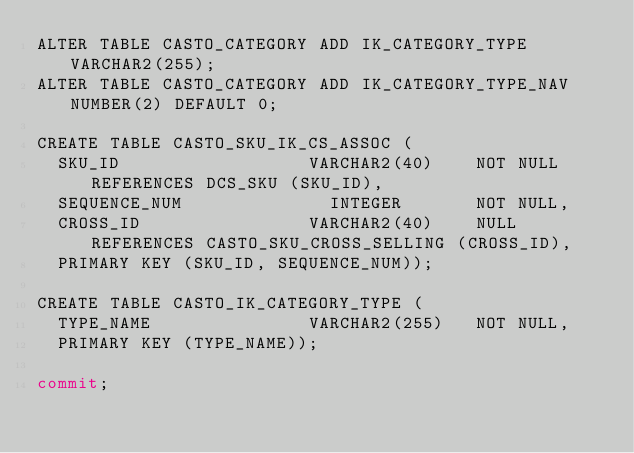<code> <loc_0><loc_0><loc_500><loc_500><_SQL_>ALTER TABLE CASTO_CATEGORY ADD IK_CATEGORY_TYPE	VARCHAR2(255);
ALTER TABLE CASTO_CATEGORY ADD IK_CATEGORY_TYPE_NAV NUMBER(2) DEFAULT 0;

CREATE TABLE CASTO_SKU_IK_CS_ASSOC (
	SKU_ID 									VARCHAR2(40)		NOT NULL REFERENCES DCS_SKU (SKU_ID), 
	SEQUENCE_NUM 							INTEGER	 			NOT NULL, 
	CROSS_ID 								VARCHAR2(40)		NULL REFERENCES CASTO_SKU_CROSS_SELLING (CROSS_ID),
	PRIMARY KEY (SKU_ID, SEQUENCE_NUM));	

CREATE TABLE CASTO_IK_CATEGORY_TYPE (
	TYPE_NAME								VARCHAR2(255)		NOT NULL,
	PRIMARY KEY (TYPE_NAME));

commit;</code> 